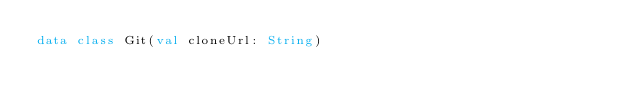<code> <loc_0><loc_0><loc_500><loc_500><_Kotlin_>data class Git(val cloneUrl: String)</code> 